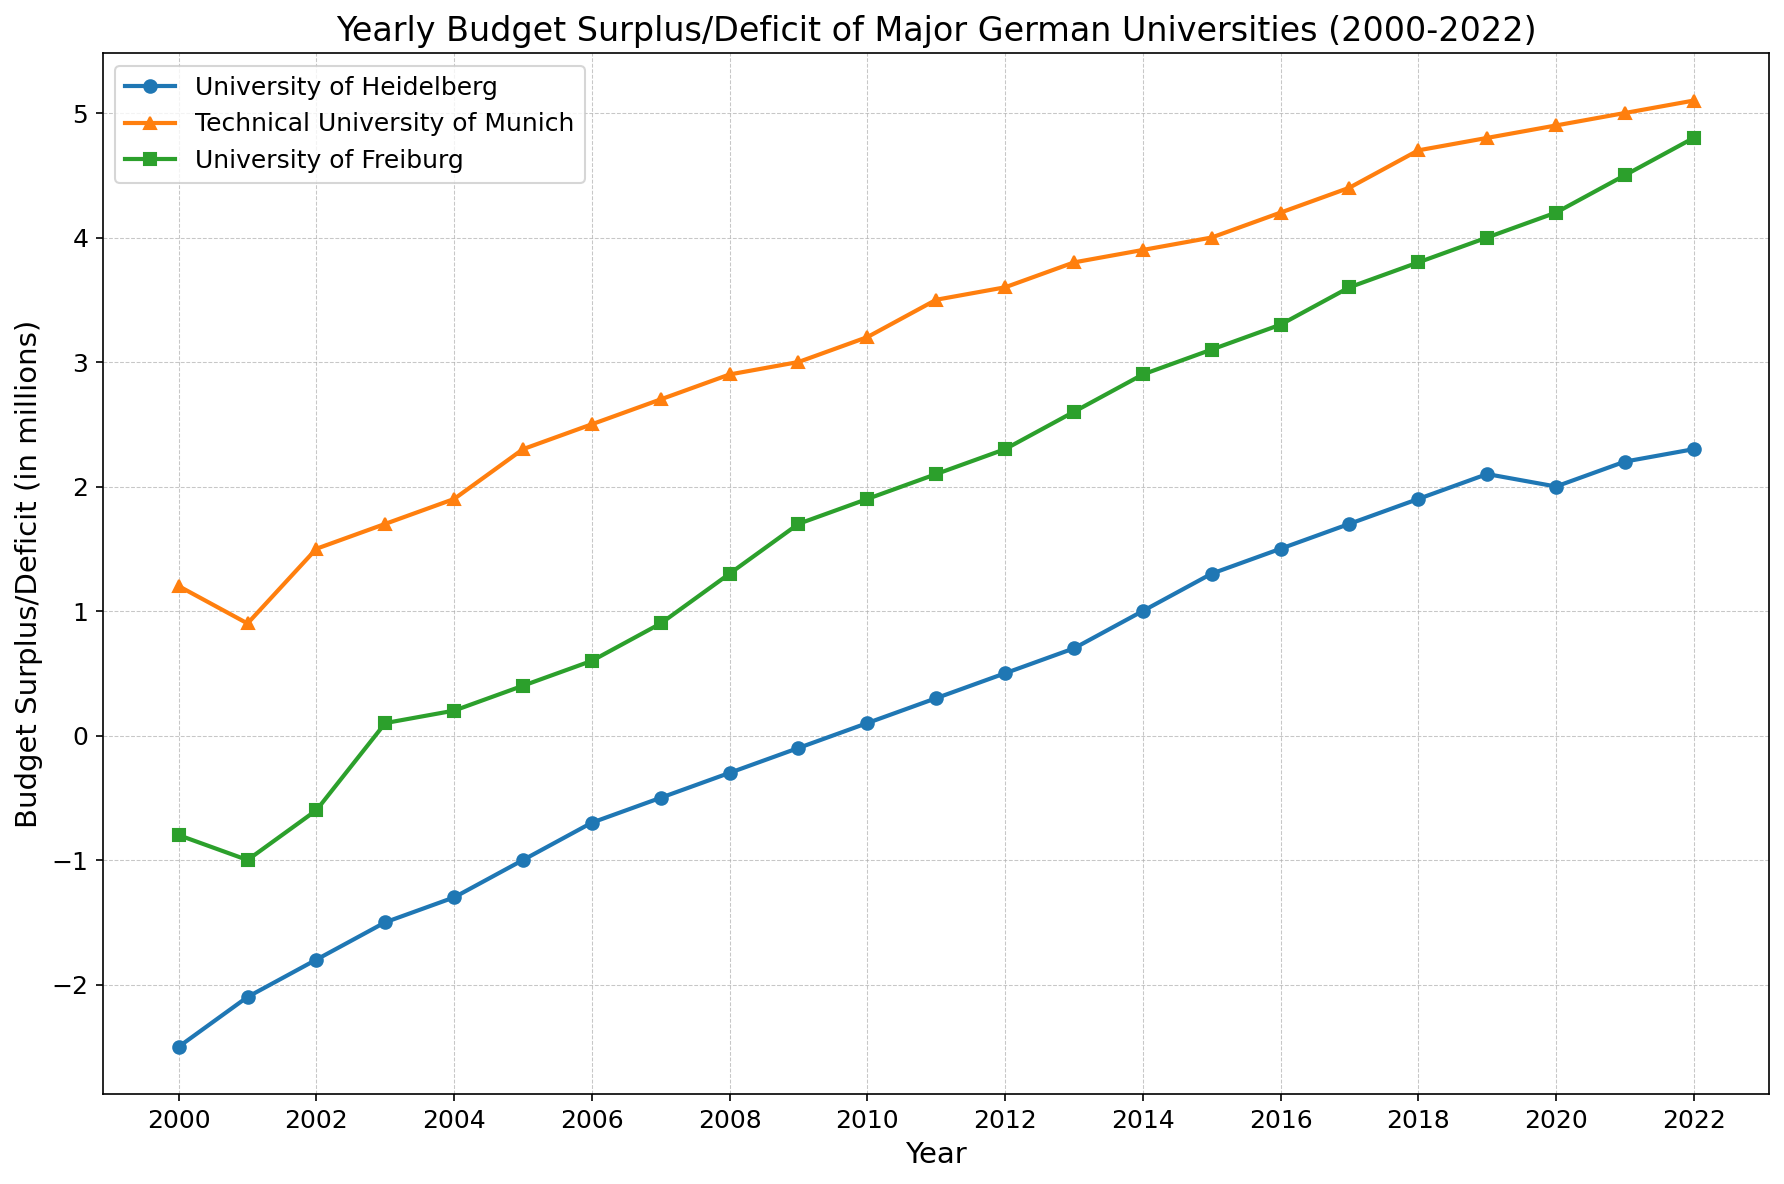What’s the trend of the University of Heidelberg's budget surplus/deficit from 2000 to 2022? Over the years, we can see that the University of Heidelberg had a deficit until around 2009 when it started to improve. From 2010 onwards, the university has seen a budget surplus that has continued to grow positively until 2022.
Answer: Positive trend In which year did the Technical University of Munich achieve the highest surplus between 2000 and 2022? By examining the line for the Technical University of Munich, we can note that the highest point is in 2022.
Answer: 2022 Which university had the highest deficit in 2000? The deficit values in 2000 are -2.5 for the University of Heidelberg, 1.2 for the Technical University of Munich (which is a surplus), and -0.8 for the University of Freiburg. Thus, the University of Heidelberg had the highest deficit.
Answer: University of Heidelberg How does the budget surplus/deficit of the University of Freiburg change from 2002 to 2008? Starting at -0.6 in 2002, the budget becomes positive at 0.1 in 2003, then progressively grows to 1.3 in 2008.
Answer: Gradually increasing What’s the difference in the surplus/deficit between the University of Freiburg and the University of Heidelberg in 2015? In 2015, the University of Freiburg had a surplus of 3.1, while the University of Heidelberg had a surplus of 1.3. The difference is 3.1 - 1.3.
Answer: 1.8 million Which university's trend line shows the most consistent growth from 2000 to 2022? By looking at the slopes and consistency of the lines, the Technical University of Munich shows the most consistent upward trend over the entire duration.
Answer: Technical University of Munich From 2006 to 2007, what change occurred in the surplus/deficit for the University of Heidelberg? The University of Heidelberg had a deficit of -0.7 in 2006 and -0.5 in 2007. The change is -0.5 - (-0.7), indicating an improvement of 0.2 million.
Answer: Increase of 0.2 million Which year did the University of Freiburg first achieve a surplus, and how much was it? The University of Freiburg first achieved a surplus in 2003 with a value of 0.1 million.
Answer: 2003, 0.1 million During which years did the University of Heidelberg have a positive budget surplus? The University of Heidelberg had a positive budget surplus from 2010 to 2022.
Answer: 2010 to 2022 What’s the average budget surplus of the Technical University of Munich from 2010 to 2022? The budget surplus values from 2010 to 2022 are 3.2, 3.5, 3.6, 3.8, 3.9, 4.0, 4.2, 4.4, 4.7, 4.8, 4.9, and 5.1. Summing these gives 50.1. Dividing by the 12 years gives an average of 50.1/12.
Answer: 4.175 million 